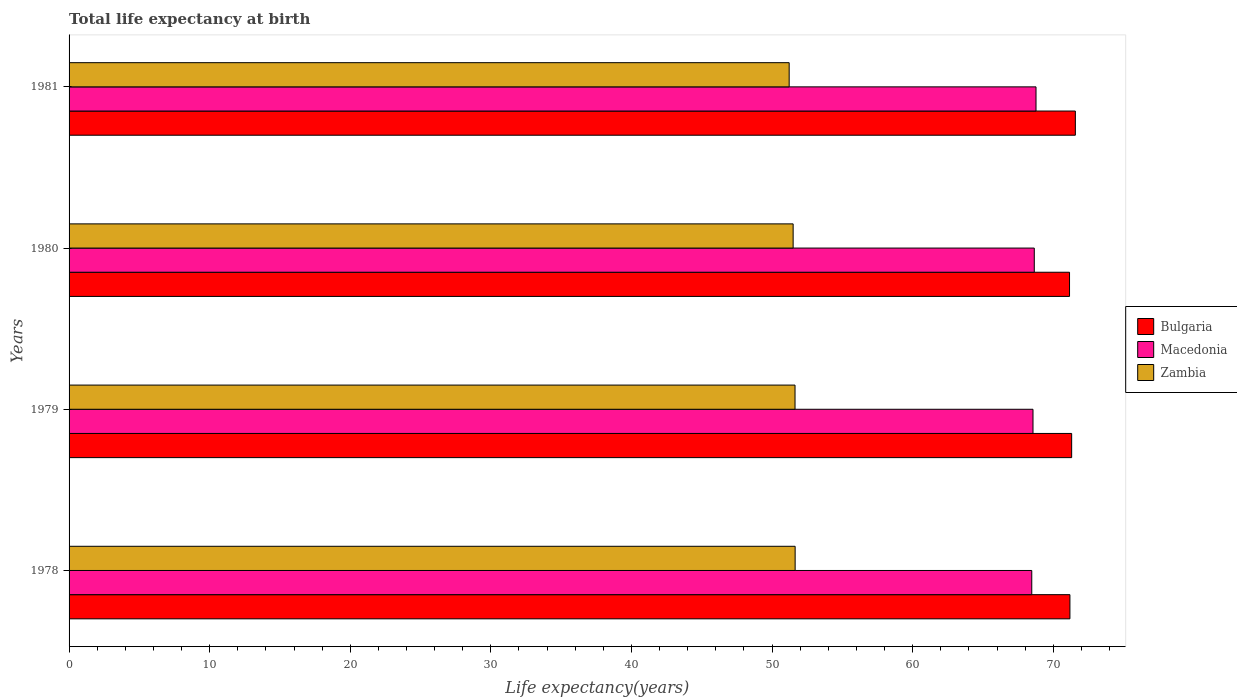How many different coloured bars are there?
Provide a succinct answer. 3. Are the number of bars on each tick of the Y-axis equal?
Provide a succinct answer. Yes. What is the label of the 3rd group of bars from the top?
Provide a succinct answer. 1979. What is the life expectancy at birth in in Zambia in 1980?
Give a very brief answer. 51.5. Across all years, what is the maximum life expectancy at birth in in Macedonia?
Make the answer very short. 68.77. Across all years, what is the minimum life expectancy at birth in in Zambia?
Make the answer very short. 51.22. In which year was the life expectancy at birth in in Macedonia minimum?
Offer a very short reply. 1978. What is the total life expectancy at birth in in Bulgaria in the graph?
Make the answer very short. 285.22. What is the difference between the life expectancy at birth in in Zambia in 1978 and that in 1979?
Offer a very short reply. 0.01. What is the difference between the life expectancy at birth in in Bulgaria in 1979 and the life expectancy at birth in in Zambia in 1978?
Offer a very short reply. 19.67. What is the average life expectancy at birth in in Bulgaria per year?
Ensure brevity in your answer.  71.31. In the year 1978, what is the difference between the life expectancy at birth in in Bulgaria and life expectancy at birth in in Zambia?
Ensure brevity in your answer.  19.54. What is the ratio of the life expectancy at birth in in Zambia in 1980 to that in 1981?
Offer a very short reply. 1.01. Is the life expectancy at birth in in Macedonia in 1978 less than that in 1979?
Provide a succinct answer. Yes. Is the difference between the life expectancy at birth in in Bulgaria in 1978 and 1981 greater than the difference between the life expectancy at birth in in Zambia in 1978 and 1981?
Provide a short and direct response. No. What is the difference between the highest and the second highest life expectancy at birth in in Bulgaria?
Keep it short and to the point. 0.26. What is the difference between the highest and the lowest life expectancy at birth in in Macedonia?
Provide a succinct answer. 0.3. In how many years, is the life expectancy at birth in in Zambia greater than the average life expectancy at birth in in Zambia taken over all years?
Keep it short and to the point. 3. What does the 2nd bar from the top in 1978 represents?
Give a very brief answer. Macedonia. What does the 3rd bar from the bottom in 1981 represents?
Make the answer very short. Zambia. How many bars are there?
Provide a succinct answer. 12. Are all the bars in the graph horizontal?
Offer a very short reply. Yes. How many years are there in the graph?
Keep it short and to the point. 4. What is the difference between two consecutive major ticks on the X-axis?
Offer a terse response. 10. What is the title of the graph?
Provide a succinct answer. Total life expectancy at birth. Does "Grenada" appear as one of the legend labels in the graph?
Provide a succinct answer. No. What is the label or title of the X-axis?
Ensure brevity in your answer.  Life expectancy(years). What is the Life expectancy(years) in Bulgaria in 1978?
Provide a succinct answer. 71.18. What is the Life expectancy(years) in Macedonia in 1978?
Make the answer very short. 68.47. What is the Life expectancy(years) of Zambia in 1978?
Provide a succinct answer. 51.64. What is the Life expectancy(years) in Bulgaria in 1979?
Your answer should be compact. 71.31. What is the Life expectancy(years) in Macedonia in 1979?
Your answer should be very brief. 68.56. What is the Life expectancy(years) in Zambia in 1979?
Provide a succinct answer. 51.63. What is the Life expectancy(years) in Bulgaria in 1980?
Your response must be concise. 71.16. What is the Life expectancy(years) in Macedonia in 1980?
Offer a very short reply. 68.65. What is the Life expectancy(years) in Zambia in 1980?
Provide a succinct answer. 51.5. What is the Life expectancy(years) of Bulgaria in 1981?
Your answer should be compact. 71.57. What is the Life expectancy(years) in Macedonia in 1981?
Give a very brief answer. 68.77. What is the Life expectancy(years) in Zambia in 1981?
Your answer should be compact. 51.22. Across all years, what is the maximum Life expectancy(years) of Bulgaria?
Offer a very short reply. 71.57. Across all years, what is the maximum Life expectancy(years) in Macedonia?
Your response must be concise. 68.77. Across all years, what is the maximum Life expectancy(years) in Zambia?
Your answer should be compact. 51.64. Across all years, what is the minimum Life expectancy(years) in Bulgaria?
Ensure brevity in your answer.  71.16. Across all years, what is the minimum Life expectancy(years) in Macedonia?
Your answer should be very brief. 68.47. Across all years, what is the minimum Life expectancy(years) of Zambia?
Make the answer very short. 51.22. What is the total Life expectancy(years) in Bulgaria in the graph?
Your answer should be compact. 285.22. What is the total Life expectancy(years) of Macedonia in the graph?
Give a very brief answer. 274.45. What is the total Life expectancy(years) in Zambia in the graph?
Make the answer very short. 205.99. What is the difference between the Life expectancy(years) of Bulgaria in 1978 and that in 1979?
Your response must be concise. -0.12. What is the difference between the Life expectancy(years) of Macedonia in 1978 and that in 1979?
Ensure brevity in your answer.  -0.09. What is the difference between the Life expectancy(years) in Zambia in 1978 and that in 1979?
Provide a short and direct response. 0.01. What is the difference between the Life expectancy(years) in Bulgaria in 1978 and that in 1980?
Give a very brief answer. 0.03. What is the difference between the Life expectancy(years) in Macedonia in 1978 and that in 1980?
Your response must be concise. -0.18. What is the difference between the Life expectancy(years) in Zambia in 1978 and that in 1980?
Give a very brief answer. 0.14. What is the difference between the Life expectancy(years) of Bulgaria in 1978 and that in 1981?
Keep it short and to the point. -0.39. What is the difference between the Life expectancy(years) in Macedonia in 1978 and that in 1981?
Make the answer very short. -0.3. What is the difference between the Life expectancy(years) of Zambia in 1978 and that in 1981?
Offer a terse response. 0.42. What is the difference between the Life expectancy(years) in Bulgaria in 1979 and that in 1980?
Your answer should be compact. 0.15. What is the difference between the Life expectancy(years) in Macedonia in 1979 and that in 1980?
Your answer should be compact. -0.09. What is the difference between the Life expectancy(years) in Zambia in 1979 and that in 1980?
Your answer should be very brief. 0.13. What is the difference between the Life expectancy(years) of Bulgaria in 1979 and that in 1981?
Offer a very short reply. -0.26. What is the difference between the Life expectancy(years) in Macedonia in 1979 and that in 1981?
Your answer should be very brief. -0.21. What is the difference between the Life expectancy(years) of Zambia in 1979 and that in 1981?
Make the answer very short. 0.42. What is the difference between the Life expectancy(years) of Bulgaria in 1980 and that in 1981?
Offer a very short reply. -0.41. What is the difference between the Life expectancy(years) in Macedonia in 1980 and that in 1981?
Give a very brief answer. -0.12. What is the difference between the Life expectancy(years) of Zambia in 1980 and that in 1981?
Your answer should be compact. 0.28. What is the difference between the Life expectancy(years) of Bulgaria in 1978 and the Life expectancy(years) of Macedonia in 1979?
Ensure brevity in your answer.  2.63. What is the difference between the Life expectancy(years) in Bulgaria in 1978 and the Life expectancy(years) in Zambia in 1979?
Keep it short and to the point. 19.55. What is the difference between the Life expectancy(years) of Macedonia in 1978 and the Life expectancy(years) of Zambia in 1979?
Your answer should be compact. 16.84. What is the difference between the Life expectancy(years) of Bulgaria in 1978 and the Life expectancy(years) of Macedonia in 1980?
Make the answer very short. 2.53. What is the difference between the Life expectancy(years) in Bulgaria in 1978 and the Life expectancy(years) in Zambia in 1980?
Your answer should be compact. 19.69. What is the difference between the Life expectancy(years) of Macedonia in 1978 and the Life expectancy(years) of Zambia in 1980?
Keep it short and to the point. 16.97. What is the difference between the Life expectancy(years) in Bulgaria in 1978 and the Life expectancy(years) in Macedonia in 1981?
Your answer should be very brief. 2.41. What is the difference between the Life expectancy(years) of Bulgaria in 1978 and the Life expectancy(years) of Zambia in 1981?
Your answer should be very brief. 19.97. What is the difference between the Life expectancy(years) in Macedonia in 1978 and the Life expectancy(years) in Zambia in 1981?
Ensure brevity in your answer.  17.25. What is the difference between the Life expectancy(years) of Bulgaria in 1979 and the Life expectancy(years) of Macedonia in 1980?
Keep it short and to the point. 2.66. What is the difference between the Life expectancy(years) in Bulgaria in 1979 and the Life expectancy(years) in Zambia in 1980?
Provide a succinct answer. 19.81. What is the difference between the Life expectancy(years) in Macedonia in 1979 and the Life expectancy(years) in Zambia in 1980?
Provide a short and direct response. 17.06. What is the difference between the Life expectancy(years) in Bulgaria in 1979 and the Life expectancy(years) in Macedonia in 1981?
Your answer should be very brief. 2.53. What is the difference between the Life expectancy(years) of Bulgaria in 1979 and the Life expectancy(years) of Zambia in 1981?
Your answer should be compact. 20.09. What is the difference between the Life expectancy(years) in Macedonia in 1979 and the Life expectancy(years) in Zambia in 1981?
Give a very brief answer. 17.34. What is the difference between the Life expectancy(years) in Bulgaria in 1980 and the Life expectancy(years) in Macedonia in 1981?
Give a very brief answer. 2.38. What is the difference between the Life expectancy(years) in Bulgaria in 1980 and the Life expectancy(years) in Zambia in 1981?
Keep it short and to the point. 19.94. What is the difference between the Life expectancy(years) of Macedonia in 1980 and the Life expectancy(years) of Zambia in 1981?
Keep it short and to the point. 17.43. What is the average Life expectancy(years) in Bulgaria per year?
Offer a terse response. 71.31. What is the average Life expectancy(years) in Macedonia per year?
Your response must be concise. 68.61. What is the average Life expectancy(years) in Zambia per year?
Offer a very short reply. 51.5. In the year 1978, what is the difference between the Life expectancy(years) in Bulgaria and Life expectancy(years) in Macedonia?
Your answer should be compact. 2.71. In the year 1978, what is the difference between the Life expectancy(years) of Bulgaria and Life expectancy(years) of Zambia?
Offer a very short reply. 19.54. In the year 1978, what is the difference between the Life expectancy(years) in Macedonia and Life expectancy(years) in Zambia?
Offer a very short reply. 16.83. In the year 1979, what is the difference between the Life expectancy(years) in Bulgaria and Life expectancy(years) in Macedonia?
Ensure brevity in your answer.  2.75. In the year 1979, what is the difference between the Life expectancy(years) of Bulgaria and Life expectancy(years) of Zambia?
Keep it short and to the point. 19.68. In the year 1979, what is the difference between the Life expectancy(years) in Macedonia and Life expectancy(years) in Zambia?
Provide a short and direct response. 16.93. In the year 1980, what is the difference between the Life expectancy(years) in Bulgaria and Life expectancy(years) in Macedonia?
Offer a terse response. 2.51. In the year 1980, what is the difference between the Life expectancy(years) in Bulgaria and Life expectancy(years) in Zambia?
Make the answer very short. 19.66. In the year 1980, what is the difference between the Life expectancy(years) in Macedonia and Life expectancy(years) in Zambia?
Ensure brevity in your answer.  17.15. In the year 1981, what is the difference between the Life expectancy(years) of Bulgaria and Life expectancy(years) of Macedonia?
Provide a short and direct response. 2.8. In the year 1981, what is the difference between the Life expectancy(years) in Bulgaria and Life expectancy(years) in Zambia?
Give a very brief answer. 20.35. In the year 1981, what is the difference between the Life expectancy(years) in Macedonia and Life expectancy(years) in Zambia?
Keep it short and to the point. 17.56. What is the ratio of the Life expectancy(years) in Bulgaria in 1978 to that in 1979?
Your answer should be very brief. 1. What is the ratio of the Life expectancy(years) in Macedonia in 1978 to that in 1979?
Keep it short and to the point. 1. What is the ratio of the Life expectancy(years) in Zambia in 1978 to that in 1979?
Make the answer very short. 1. What is the ratio of the Life expectancy(years) of Macedonia in 1978 to that in 1980?
Your answer should be very brief. 1. What is the ratio of the Life expectancy(years) in Zambia in 1978 to that in 1980?
Your answer should be very brief. 1. What is the ratio of the Life expectancy(years) in Bulgaria in 1978 to that in 1981?
Give a very brief answer. 0.99. What is the ratio of the Life expectancy(years) of Zambia in 1978 to that in 1981?
Ensure brevity in your answer.  1.01. What is the ratio of the Life expectancy(years) in Zambia in 1979 to that in 1980?
Keep it short and to the point. 1. What is the ratio of the Life expectancy(years) of Macedonia in 1980 to that in 1981?
Give a very brief answer. 1. What is the ratio of the Life expectancy(years) in Zambia in 1980 to that in 1981?
Keep it short and to the point. 1.01. What is the difference between the highest and the second highest Life expectancy(years) in Bulgaria?
Provide a succinct answer. 0.26. What is the difference between the highest and the second highest Life expectancy(years) of Macedonia?
Provide a short and direct response. 0.12. What is the difference between the highest and the second highest Life expectancy(years) in Zambia?
Ensure brevity in your answer.  0.01. What is the difference between the highest and the lowest Life expectancy(years) in Bulgaria?
Offer a very short reply. 0.41. What is the difference between the highest and the lowest Life expectancy(years) in Macedonia?
Give a very brief answer. 0.3. What is the difference between the highest and the lowest Life expectancy(years) of Zambia?
Offer a very short reply. 0.42. 